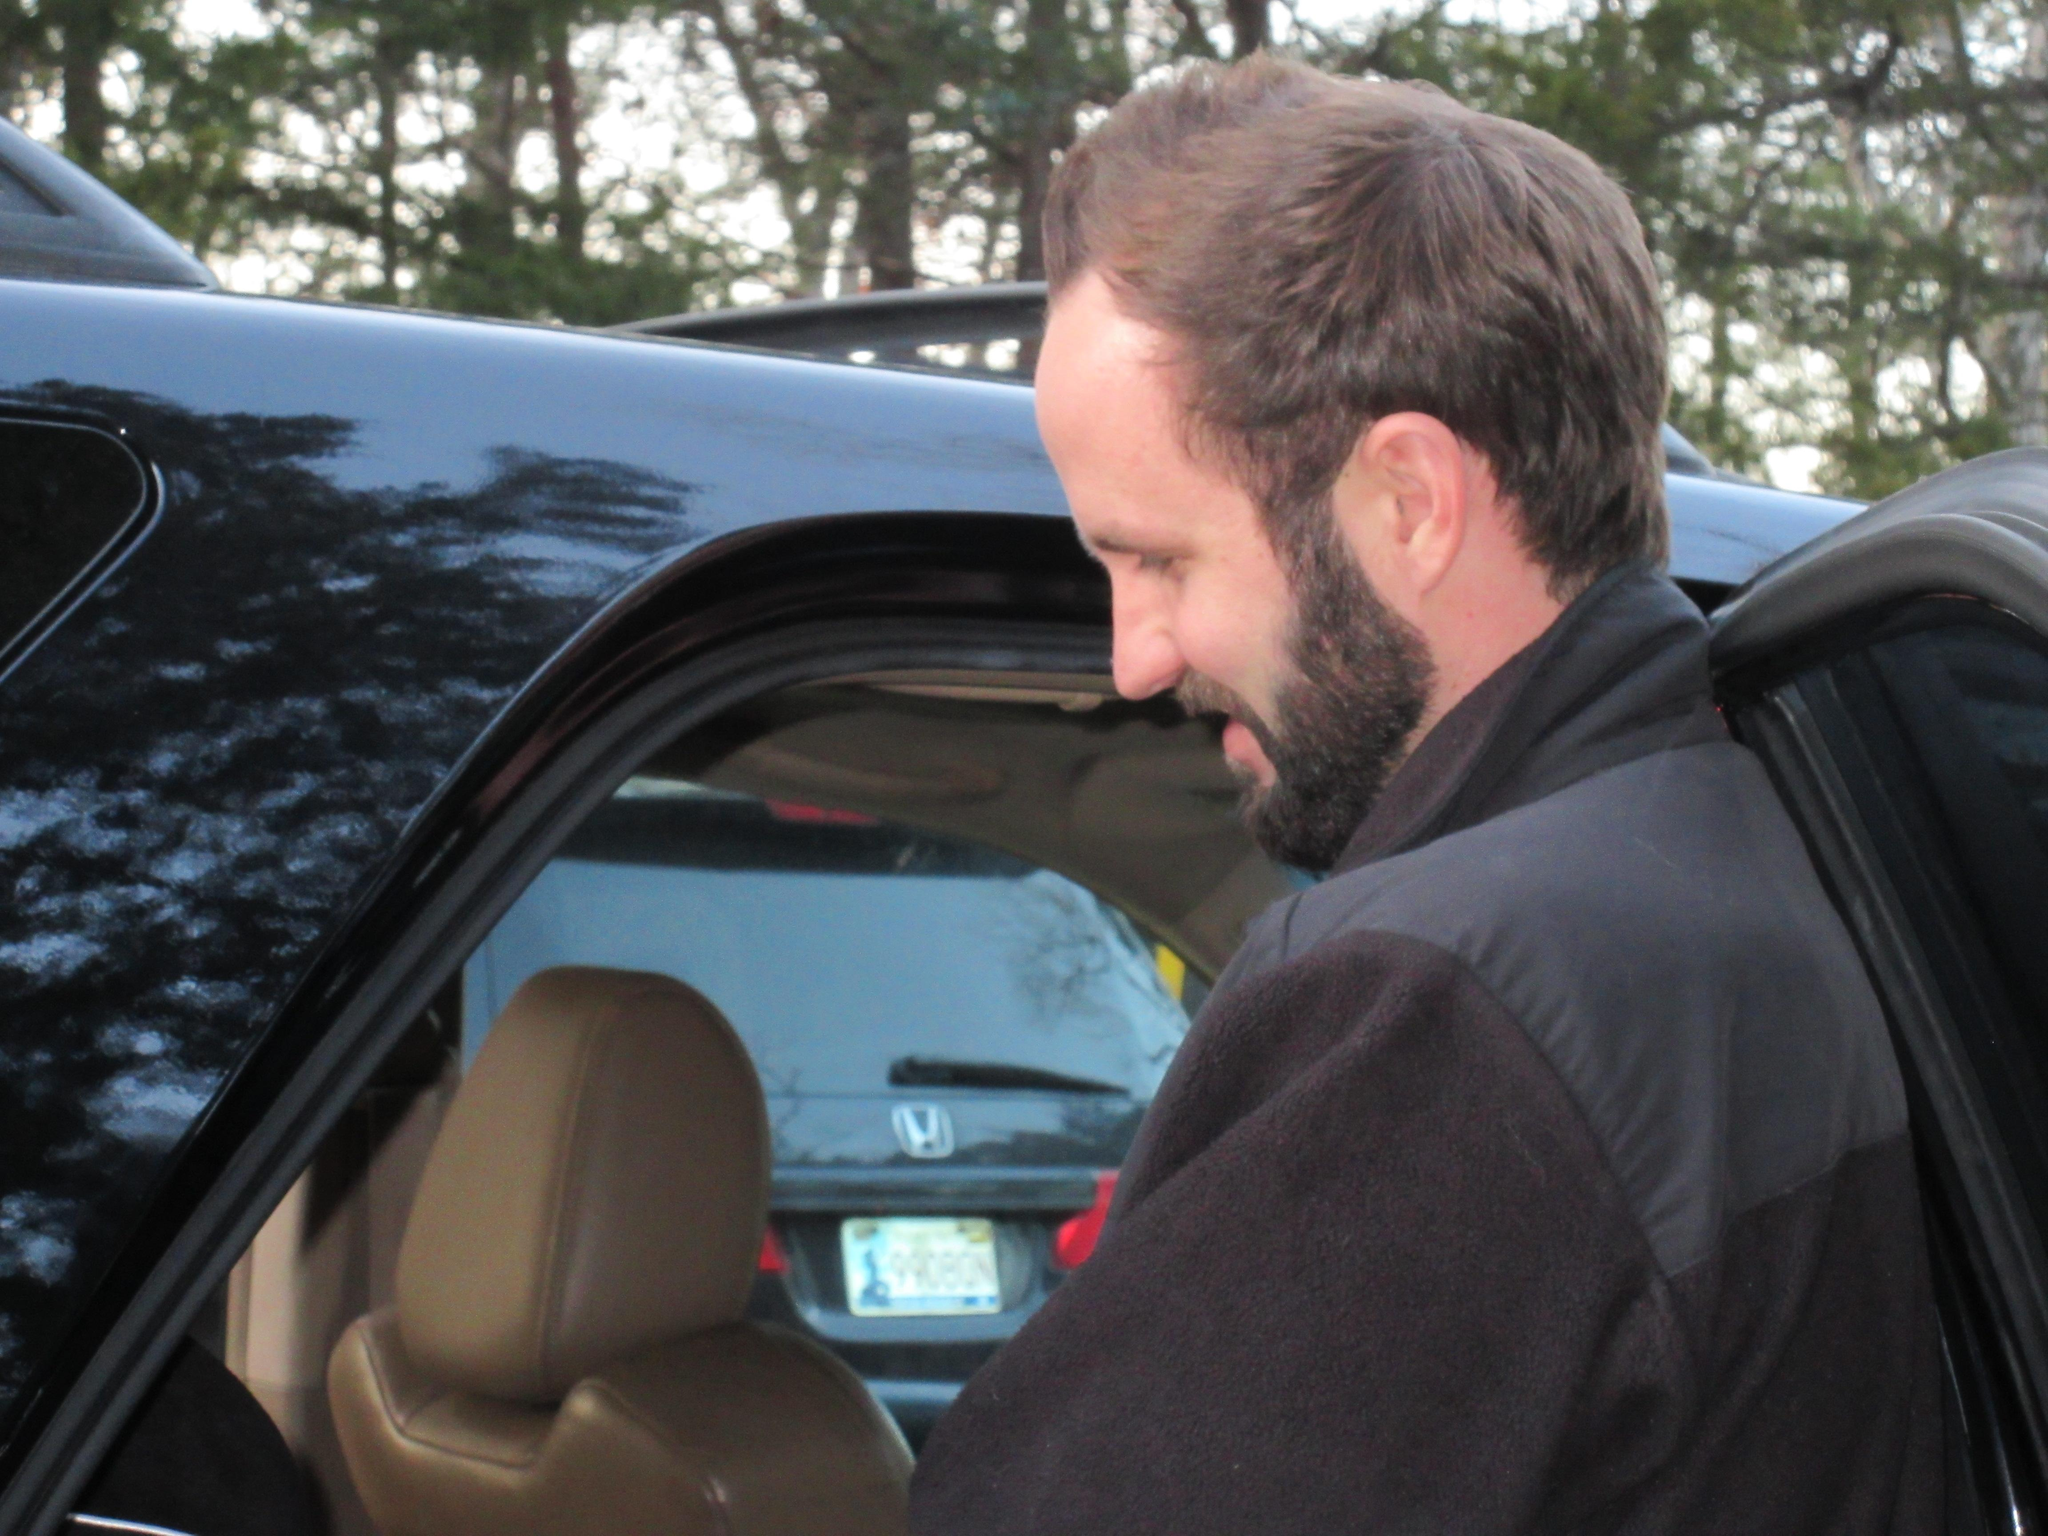Who is present in the image? There is a man in the image. What is the man doing in the image? The man is standing beside a car. What can be seen in the background of the image? There are trees visible in the background of the image. Are there any other vehicles in the image? Yes, there is another car in the background of the image. What type of yoke is being used to control the car in the image? There is no yoke present in the image, as cars are typically controlled using a steering wheel. 